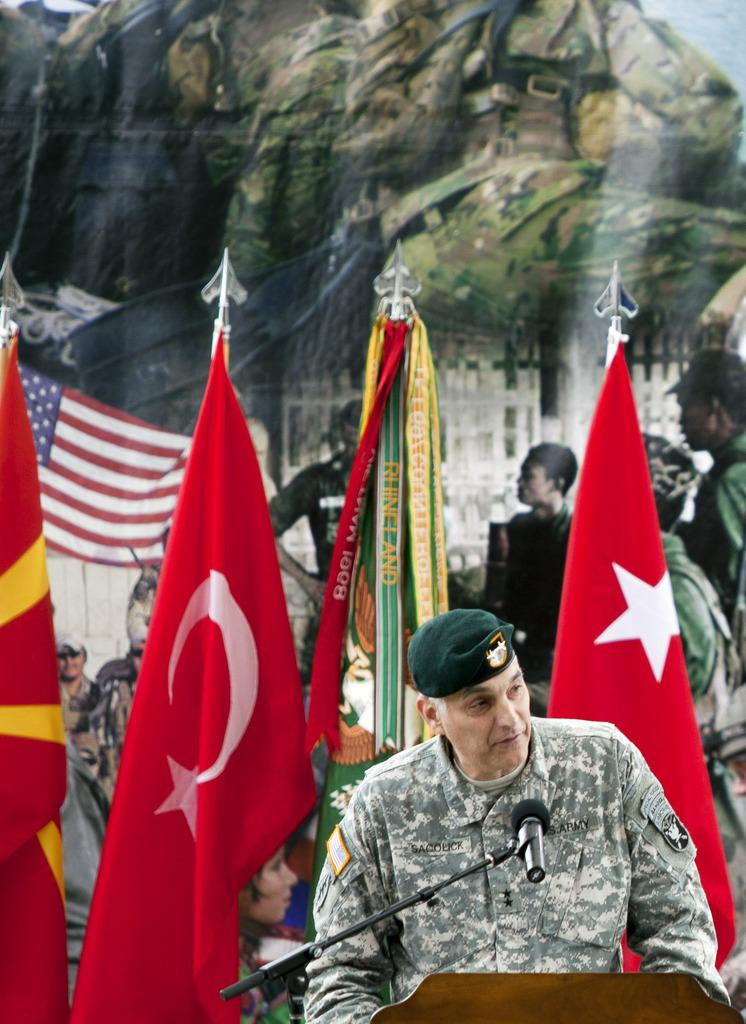What is the main subject of the image? The main subject of the image is an army man. Where is the army man positioned in the image? The army man is standing in front of a podium. What is the army man likely to use in the image? There is a microphone (mike) in the image, which the army man might use for speaking. What can be seen in the background of the image? There are different flags and a poster with army people in the background of the image. What type of scent can be detected coming from the army man in the image? There is no indication of any scent in the image, as it is a visual representation and does not convey smells. 